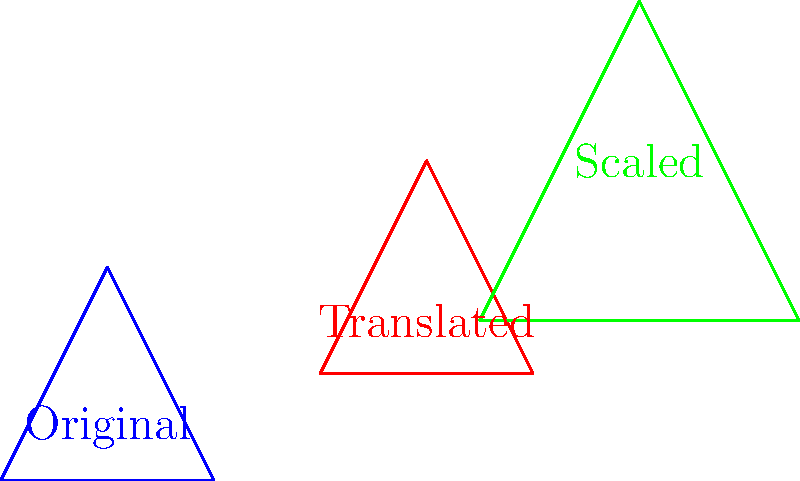In the Turkish War of Independence, a military strategist is planning troop movements using geometric transformations. The original troop formation is represented by a triangle with vertices at (0,0), (2,0), and (1,2). The formation is first translated 3 units right and 1 unit up, then scaled by a factor of 1.5 from the new position. What are the coordinates of the vertex that was originally at (1,2) after both transformations? To solve this problem, we'll follow these steps:

1. Identify the original coordinates of the vertex: (1,2)

2. Apply the translation:
   - Move 3 units right: $x' = x + 3$
   - Move 1 unit up: $y' = y + 1$
   - New coordinates after translation: $(1+3, 2+1) = (4,3)$

3. Apply the scaling transformation:
   - Scale factor: 1.5
   - Scaling formula: $(x'', y'') = (1.5x', 1.5y')$
   - Final coordinates: $(1.5 \cdot 4, 1.5 \cdot 3)$

4. Calculate the final coordinates:
   $x'' = 1.5 \cdot 4 = 6$
   $y'' = 1.5 \cdot 3 = 4.5$

Therefore, the final coordinates of the vertex originally at (1,2) after both transformations are (6, 4.5).
Answer: (6, 4.5) 